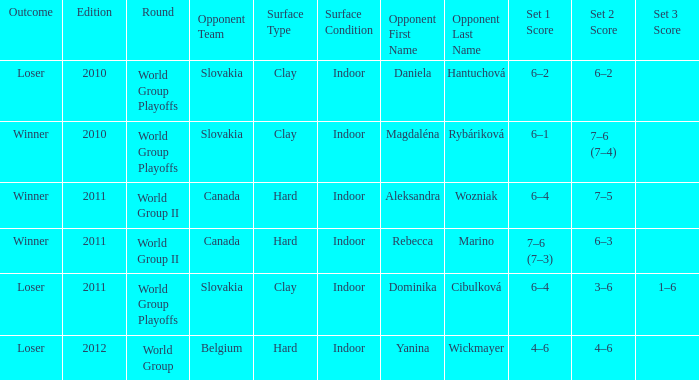What was the game edition when they played on the clay (i) surface and the outcome was a winner? 2010.0. 